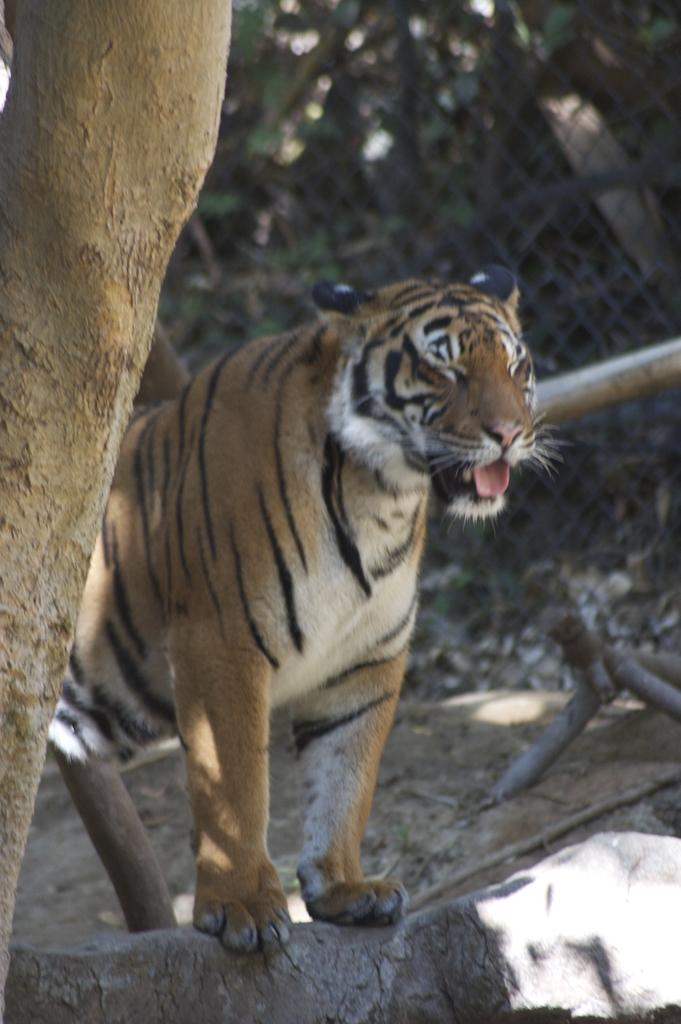What animal is present in the image? There is a tiger in the image. What object can be seen on the left side of the image? There is a tree trunk on the left side of the image. What type of material is visible in the background of the image? There is a mesh visible in the background of the image. How would you describe the appearance of the background in the image? The background appears blurry. How many cakes are being used as cushions for the tiger in the image? There are no cakes or cushions present in the image; it features a tiger and a tree trunk with a blurry background. 